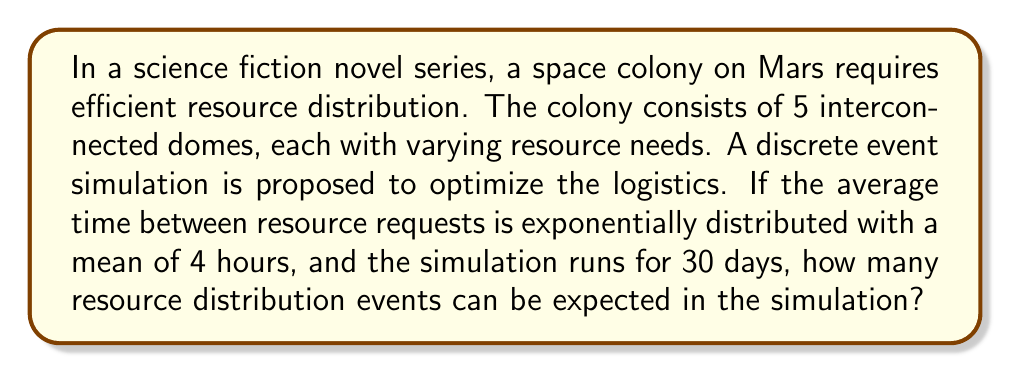Teach me how to tackle this problem. To solve this problem, we'll follow these steps:

1) First, we need to understand the properties of the exponential distribution. The exponential distribution is often used to model the time between events in a Poisson process. The rate parameter $\lambda$ is the inverse of the mean time between events.

2) Given:
   - Mean time between resource requests = 4 hours
   - Simulation duration = 30 days

3) Calculate the rate parameter $\lambda$:
   $$\lambda = \frac{1}{\text{mean time}} = \frac{1}{4} = 0.25 \text{ events/hour}$$

4) Convert the simulation duration to hours:
   $$30 \text{ days} \times 24 \text{ hours/day} = 720 \text{ hours}$$

5) The expected number of events in a Poisson process over a time period $t$ is given by $\lambda t$. Therefore, the expected number of resource distribution events is:
   $$\text{Expected events} = \lambda t = 0.25 \text{ events/hour} \times 720 \text{ hours} = 180 \text{ events}$$

Thus, we can expect approximately 180 resource distribution events in the 30-day simulation.
Answer: 180 events 